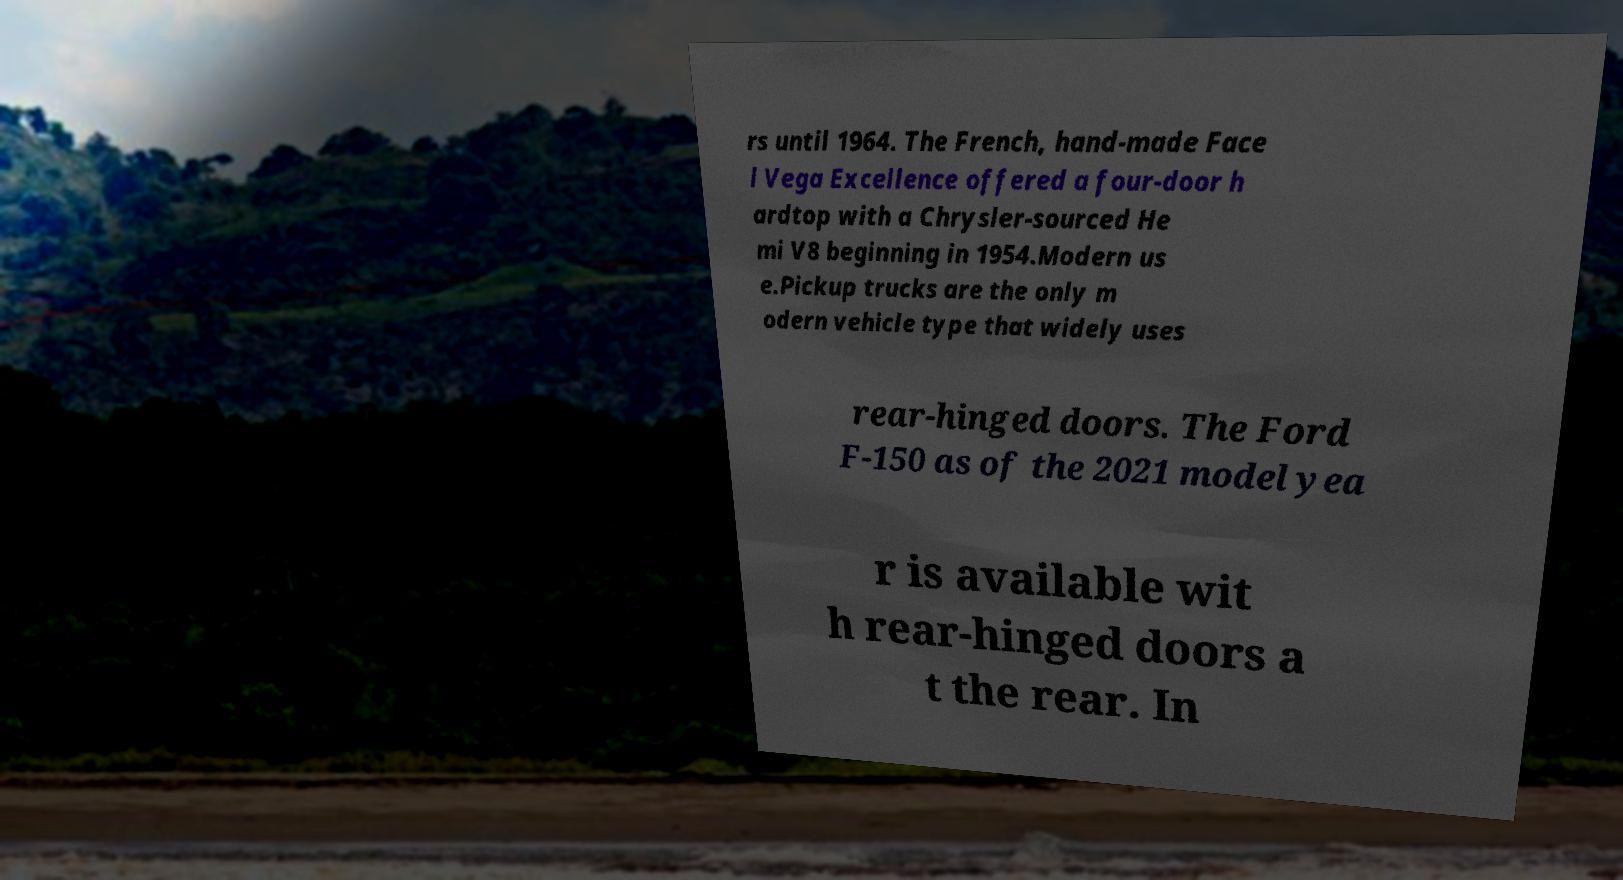Can you read and provide the text displayed in the image?This photo seems to have some interesting text. Can you extract and type it out for me? rs until 1964. The French, hand-made Face l Vega Excellence offered a four-door h ardtop with a Chrysler-sourced He mi V8 beginning in 1954.Modern us e.Pickup trucks are the only m odern vehicle type that widely uses rear-hinged doors. The Ford F-150 as of the 2021 model yea r is available wit h rear-hinged doors a t the rear. In 